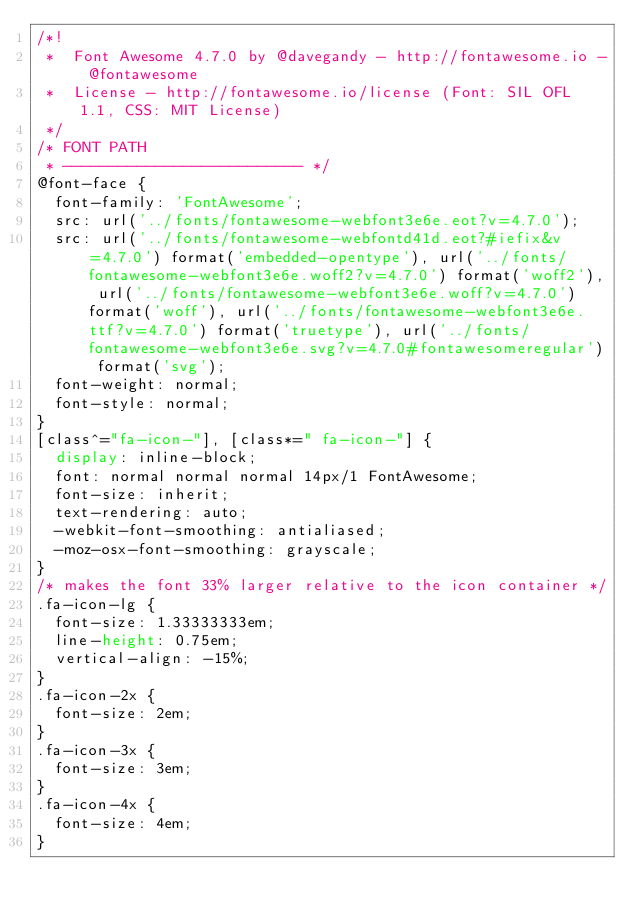<code> <loc_0><loc_0><loc_500><loc_500><_CSS_>/*!
 *  Font Awesome 4.7.0 by @davegandy - http://fontawesome.io - @fontawesome
 *  License - http://fontawesome.io/license (Font: SIL OFL 1.1, CSS: MIT License)
 */
/* FONT PATH
 * -------------------------- */
@font-face {
  font-family: 'FontAwesome';
  src: url('../fonts/fontawesome-webfont3e6e.eot?v=4.7.0');
  src: url('../fonts/fontawesome-webfontd41d.eot?#iefix&v=4.7.0') format('embedded-opentype'), url('../fonts/fontawesome-webfont3e6e.woff2?v=4.7.0') format('woff2'), url('../fonts/fontawesome-webfont3e6e.woff?v=4.7.0') format('woff'), url('../fonts/fontawesome-webfont3e6e.ttf?v=4.7.0') format('truetype'), url('../fonts/fontawesome-webfont3e6e.svg?v=4.7.0#fontawesomeregular') format('svg');
  font-weight: normal;
  font-style: normal;
}
[class^="fa-icon-"], [class*=" fa-icon-"] {
  display: inline-block;
  font: normal normal normal 14px/1 FontAwesome;
  font-size: inherit;
  text-rendering: auto;
  -webkit-font-smoothing: antialiased;
  -moz-osx-font-smoothing: grayscale;
}
/* makes the font 33% larger relative to the icon container */
.fa-icon-lg {
  font-size: 1.33333333em;
  line-height: 0.75em;
  vertical-align: -15%;
}
.fa-icon-2x {
  font-size: 2em;
}
.fa-icon-3x {
  font-size: 3em;
}
.fa-icon-4x {
  font-size: 4em;
}</code> 